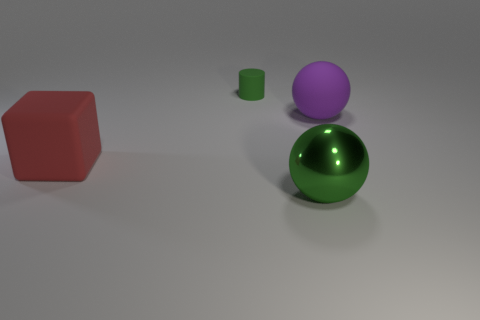What kind of mood does this image evoke, and could it be part of a larger scene? The image evokes a calm and neutral mood with its simple composition and muted background. It's possible that this could be a segment of a larger scene, perhaps a visualization for a study of geometric forms or part of a minimalist art installation. 